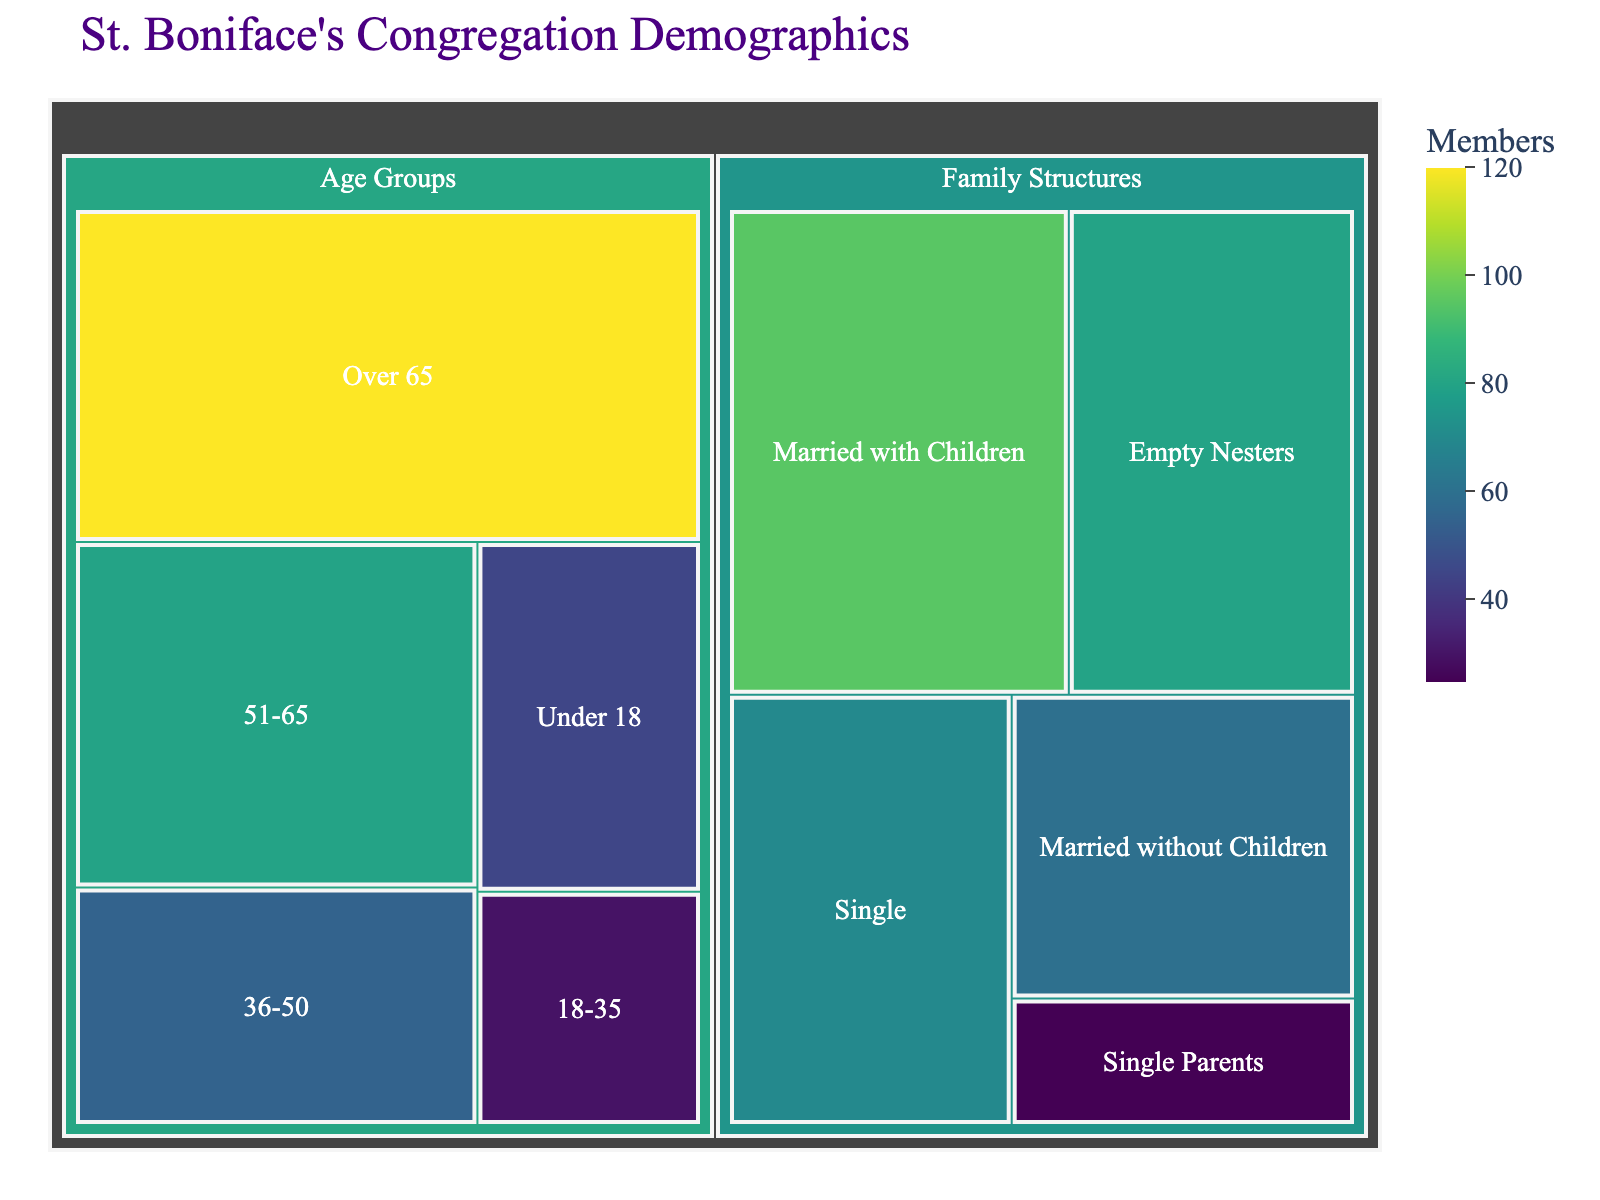What's the total membership of St. Boniface's congregation? To find the total membership, sum the values of all listed groups. The total is 45 (Under 18) + 30 (18-35) + 55 (36-50) + 80 (51-65) + 120 (Over 65) + 70 (Single) + 60 (Married without Children) + 95 (Married with Children) + 25 (Single Parents) + 80 (Empty Nesters). This equals 660 members.
Answer: 660 Which age group has the highest number of members? Look at the values under the "Age Groups" category. The "Over 65" group has the highest value, which is 120 members.
Answer: Over 65 How does the number of "Single" members compare to the number of "Married without Children" members? The figure shows that the number of "Single" members is 70, while the number of "Married without Children" members is 60. Since 70 is greater than 60, "Single" members are more numerous.
Answer: There are more "Single" members What is the sum of members in the age groups "Under 18" and "18-35"? Add the members in these two age groups: 45 (Under 18) + 30 (18-35) equals 75.
Answer: 75 Which family structure has the fewest members? Examine the "Family Structures" category. "Single Parents" has the lowest number of members at 25.
Answer: Single Parents What is the proportion of "Married with Children" members relative to the total membership? Divide the number of "Married with Children" members (95) by the total membership (660) and multiply by 100 for the percentage. (95 / 660) * 100 ≈ 14.39%.
Answer: About 14.39% How many more members are there in the "Over 65" age group compared to the "18-35" age group? Subtract the number of members in the "18-35" age group from the "Over 65" age group: 120 - 30 equals 90.
Answer: 90 Which age group appears to be larger, "36-50" or "51-65"? Compare their values: 55 (36-50) and 80 (51-65). Since 80 is greater than 55, the "51-65" age group is larger.
Answer: 51-65 What's the total number of members in the "Family Structures" category? Sum the values of all subcategories under "Family Structures": 70 (Single) + 60 (Married without Children) + 95 (Married with Children) + 25 (Single Parents) + 80 (Empty Nesters) equals 330.
Answer: 330 What is the average number of members across all family structures? Calculate the average by dividing the total number of members in "Family Structures" (330) by the number of subcategories (5). This is 330 / 5 = 66.
Answer: 66 